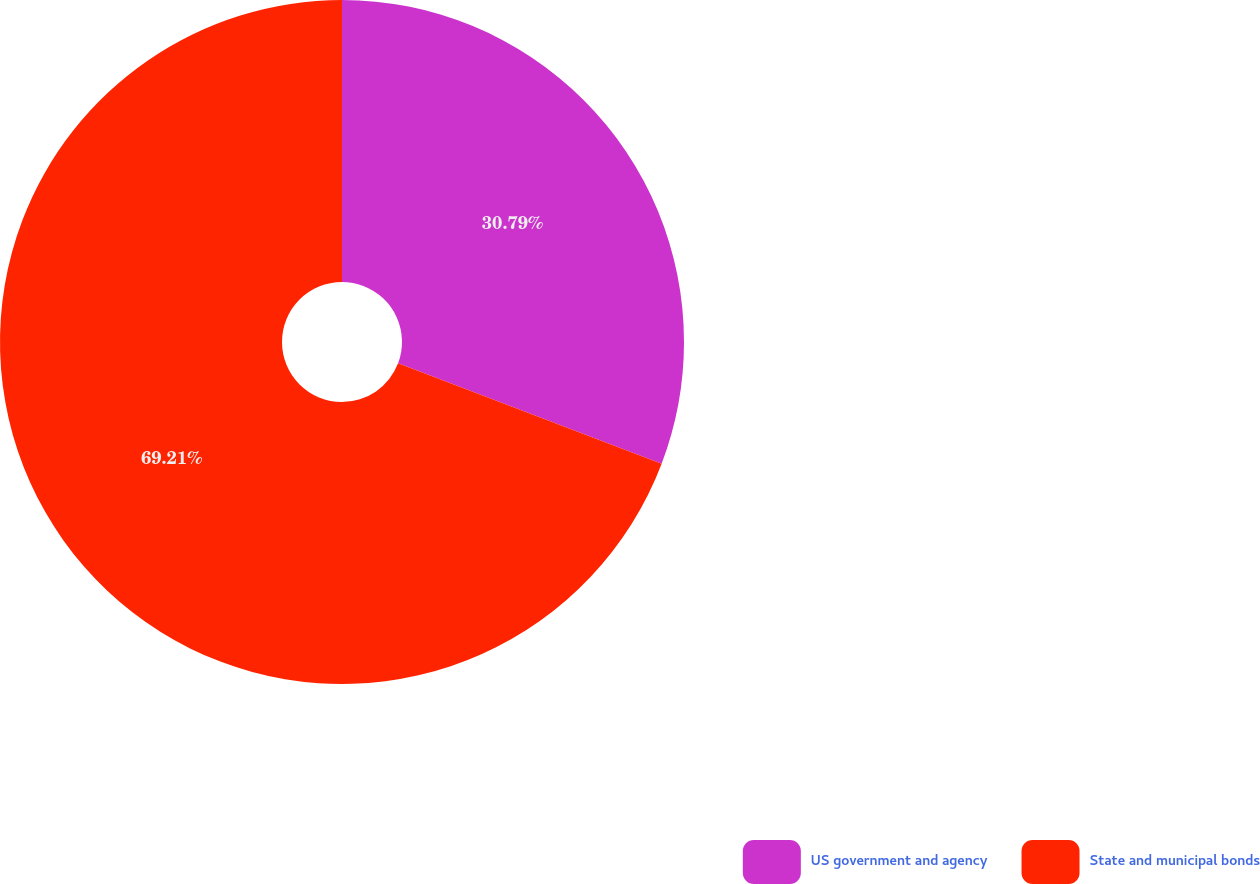Convert chart to OTSL. <chart><loc_0><loc_0><loc_500><loc_500><pie_chart><fcel>US government and agency<fcel>State and municipal bonds<nl><fcel>30.79%<fcel>69.21%<nl></chart> 